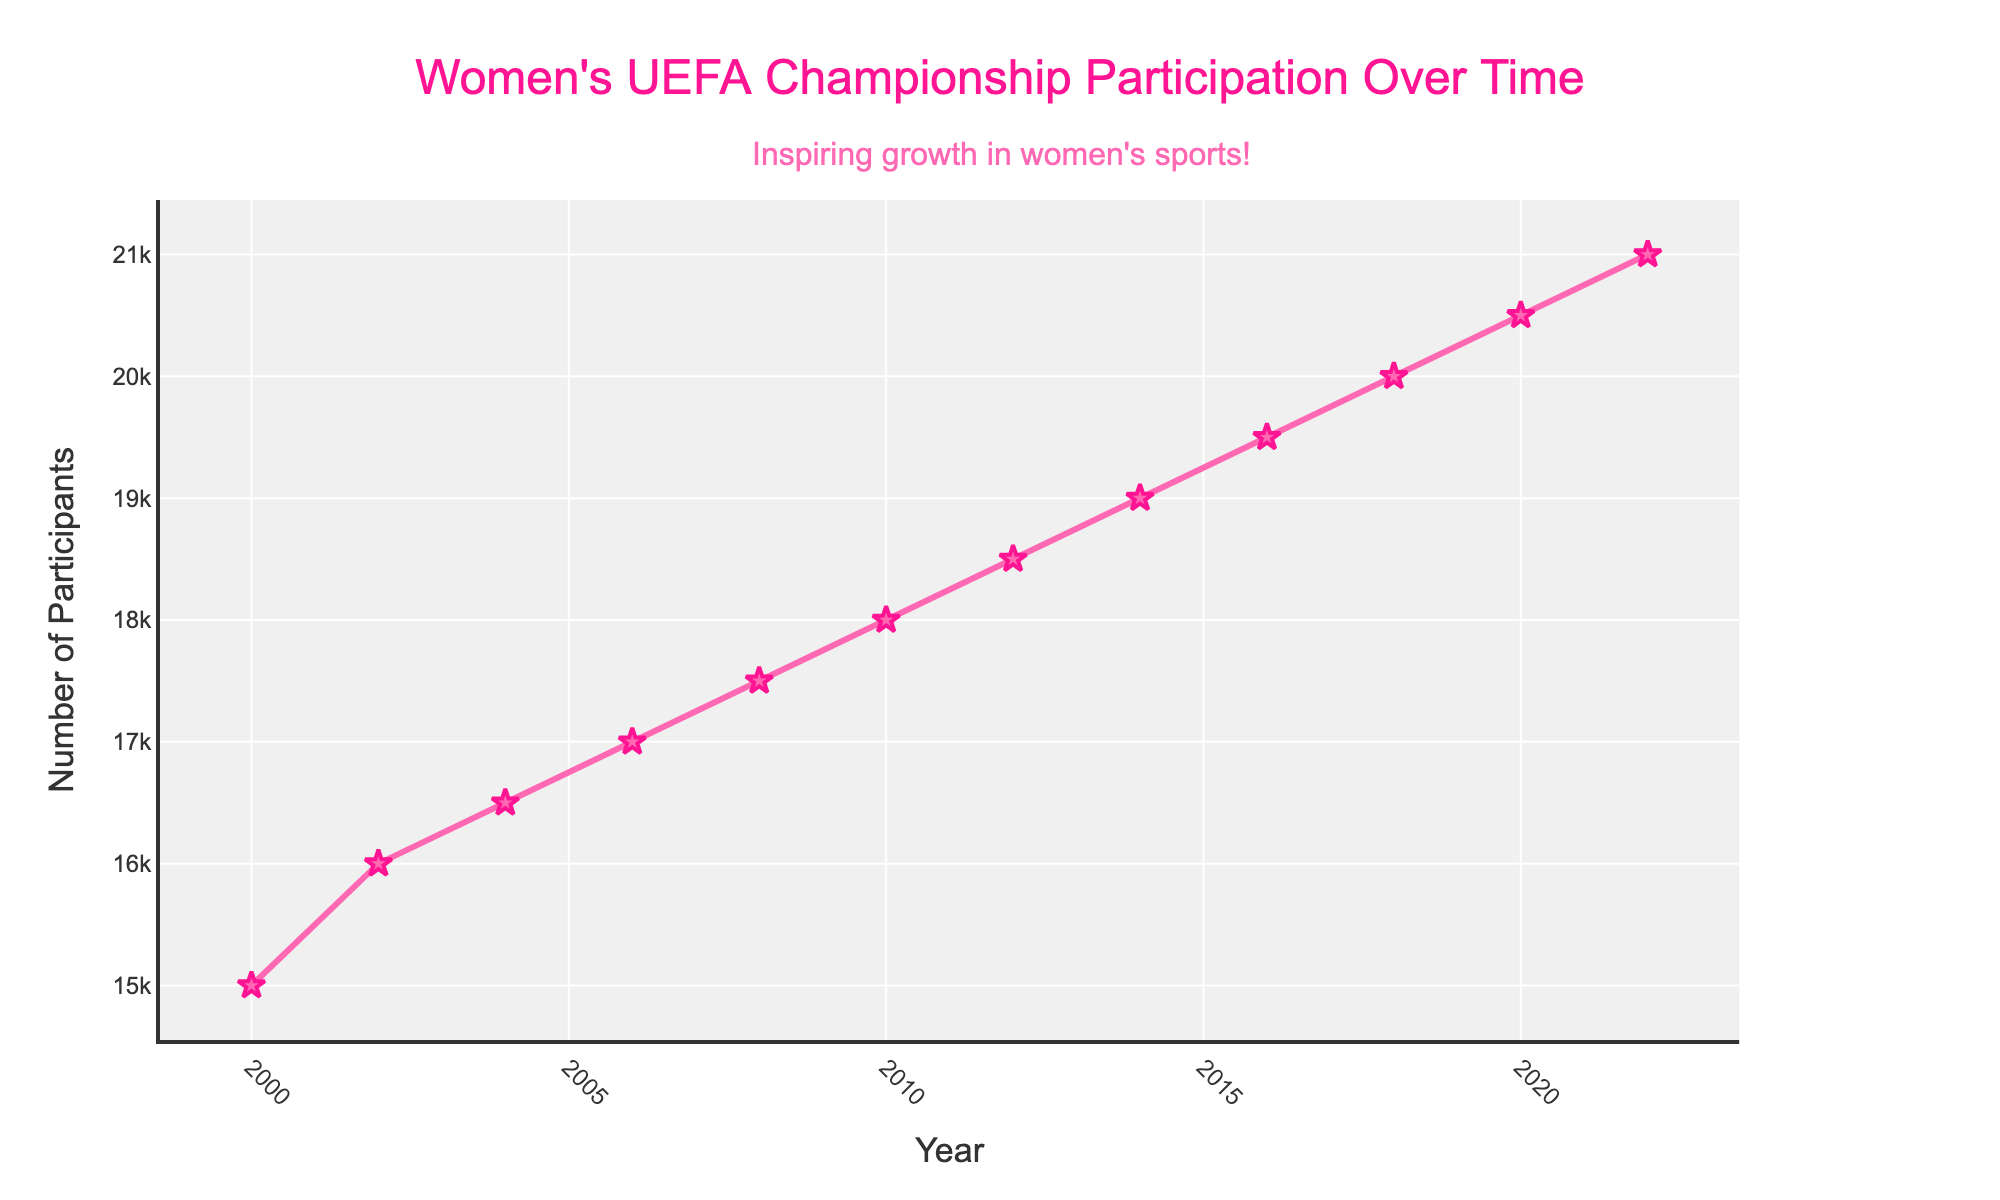what is the title of the figure? The title of the figure is displayed at the top center in large font. It reads "Women's UEFA Championship Participation Over Time."
Answer: Women's UEFA Championship Participation Over Time how many data points are there in the figure? The figure shows one data point for each year listed on the x-axis from 2000 to 2022, which includes twelve data points.
Answer: twelve what is the trend of participation over time? The y-axis shows participation counts and the x-axis indicates years. The line connecting the points trends upwards from 2000 to 2022, indicating increasing participation over time.
Answer: increasing which years have the highest and lowest participation counts? By observing the highest and lowest points along the y-axis, we see that 2022 has the highest participation count, and 2000 has the lowest.
Answer: 2022 and 2000 how does the participation count in 2022 compare to that in 2010? By comparing the y-values for the years 2022 and 2010, 2022 has a participation count of 21,000, while 2010 has 18,000, showing an increase of 3,000 participants over this period.
Answer: 3,000 increase what is the average participation count from 2000 to 2022? Sum the participation counts for all years: 15000 + 16000 + 16500 + 17000 + 17500 + 18000 + 18500 + 19000 + 19500 + 20000 + 20500 + 21000 = 218000. Divide by the number of years (12): 218000 / 12 = 18166.67.
Answer: 18,166.67 which country hosted the event with the highest participation count? The highest participation count of 21,000 in 2022 corresponds to Italy, as indicated by the data provided.
Answer: Italy how many times did Germany host the event? The data points list Germany as the host in 2000 and 2016. Therefore, Germany hosted the event twice.
Answer: twice what is the general shape of the markers on the plot? The markers along the data points are shaped like stars, as visible by the plotted symbols at each data point.
Answer: stars how does the participation count change from 2008 to 2010? By examining the participation counts for 2008 (17,500) and 2010 (18,000), the participation increased by 500.
Answer: 500 increase 